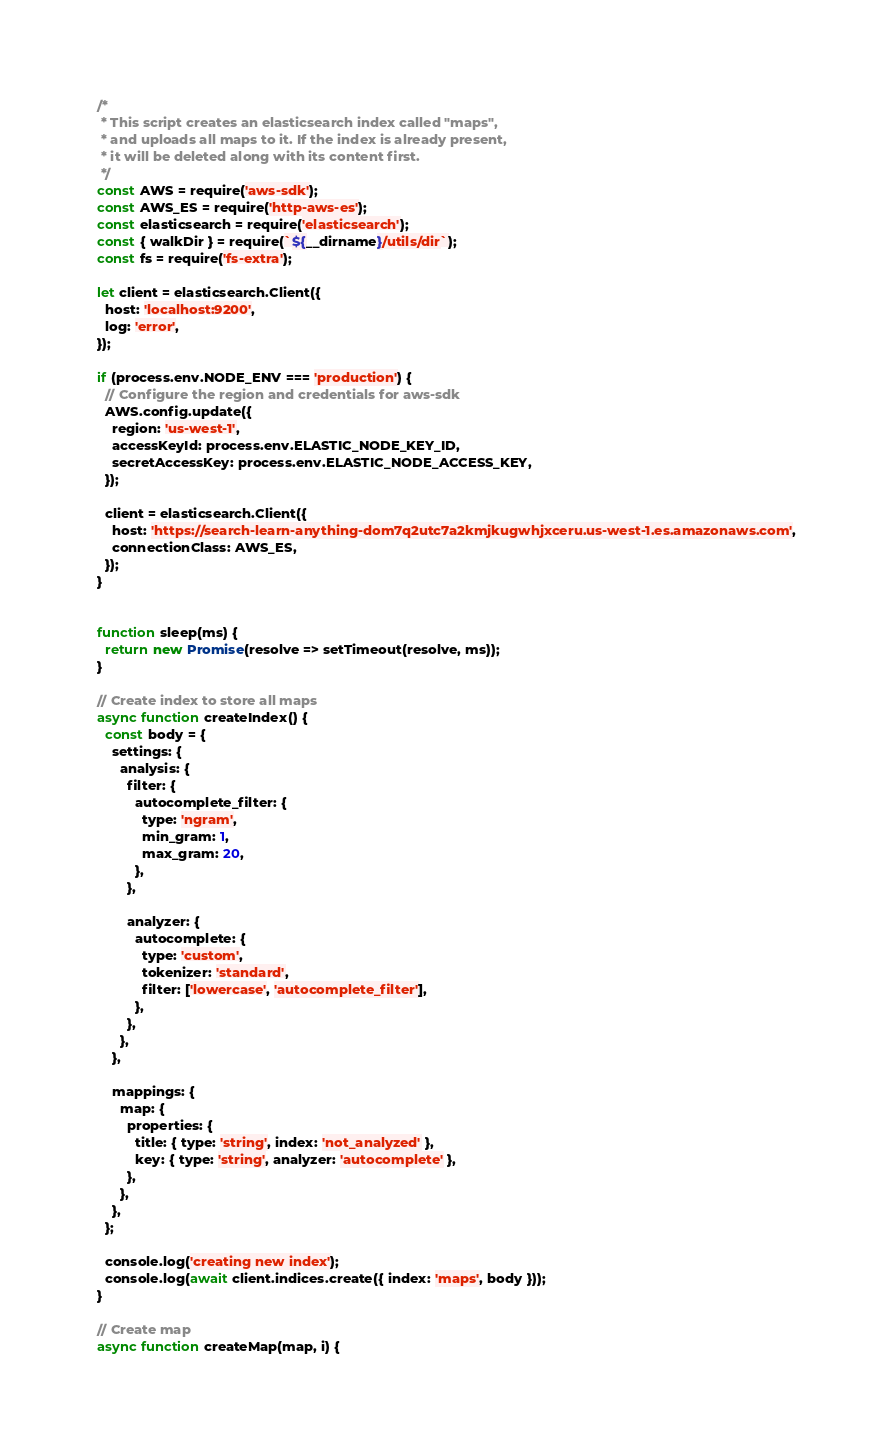Convert code to text. <code><loc_0><loc_0><loc_500><loc_500><_JavaScript_>/*
 * This script creates an elasticsearch index called "maps",
 * and uploads all maps to it. If the index is already present,
 * it will be deleted along with its content first.
 */
const AWS = require('aws-sdk');
const AWS_ES = require('http-aws-es');
const elasticsearch = require('elasticsearch');
const { walkDir } = require(`${__dirname}/utils/dir`);
const fs = require('fs-extra');

let client = elasticsearch.Client({
  host: 'localhost:9200',
  log: 'error',
});

if (process.env.NODE_ENV === 'production') {
  // Configure the region and credentials for aws-sdk
  AWS.config.update({
    region: 'us-west-1',
    accessKeyId: process.env.ELASTIC_NODE_KEY_ID,
    secretAccessKey: process.env.ELASTIC_NODE_ACCESS_KEY,
  });

  client = elasticsearch.Client({
    host: 'https://search-learn-anything-dom7q2utc7a2kmjkugwhjxceru.us-west-1.es.amazonaws.com',
    connectionClass: AWS_ES,
  });
}


function sleep(ms) {
  return new Promise(resolve => setTimeout(resolve, ms));
}

// Create index to store all maps
async function createIndex() {
  const body = {
    settings: {
      analysis: {
        filter: {
          autocomplete_filter: {
            type: 'ngram',
            min_gram: 1,
            max_gram: 20,
          },
        },

        analyzer: {
          autocomplete: {
            type: 'custom',
            tokenizer: 'standard',
            filter: ['lowercase', 'autocomplete_filter'],
          },
        },
      },
    },

    mappings: {
      map: {
        properties: {
          title: { type: 'string', index: 'not_analyzed' },
          key: { type: 'string', analyzer: 'autocomplete' },
        },
      },
    },
  };

  console.log('creating new index');
  console.log(await client.indices.create({ index: 'maps', body }));
}

// Create map
async function createMap(map, i) {</code> 